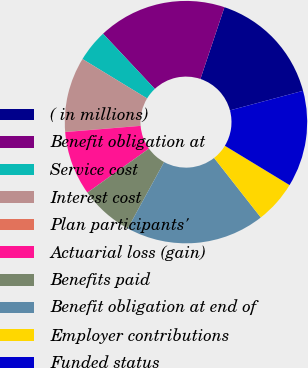Convert chart to OTSL. <chart><loc_0><loc_0><loc_500><loc_500><pie_chart><fcel>( in millions)<fcel>Benefit obligation at<fcel>Service cost<fcel>Interest cost<fcel>Plan participants'<fcel>Actuarial loss (gain)<fcel>Benefits paid<fcel>Benefit obligation at end of<fcel>Employer contributions<fcel>Funded status<nl><fcel>15.7%<fcel>17.13%<fcel>4.3%<fcel>10.0%<fcel>0.02%<fcel>8.57%<fcel>7.15%<fcel>18.56%<fcel>5.72%<fcel>12.85%<nl></chart> 